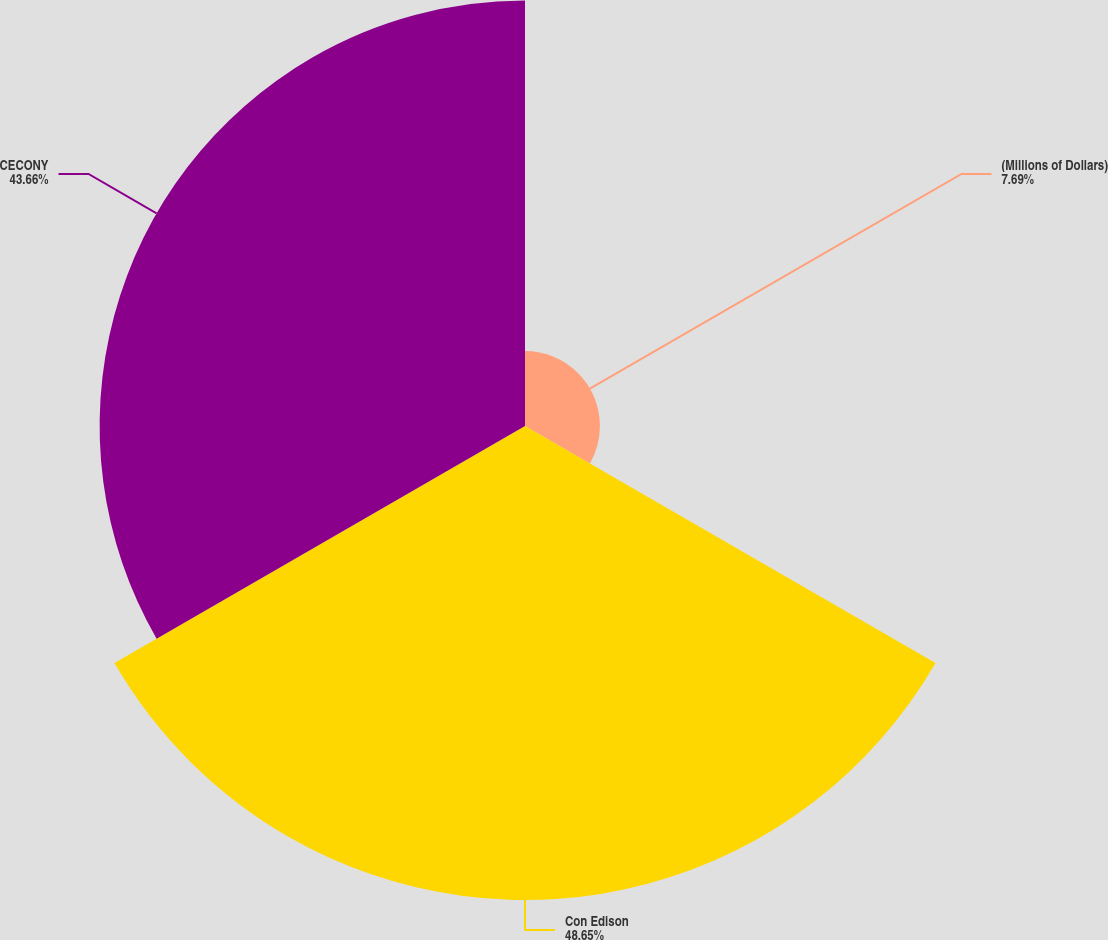Convert chart. <chart><loc_0><loc_0><loc_500><loc_500><pie_chart><fcel>(Millions of Dollars)<fcel>Con Edison<fcel>CECONY<nl><fcel>7.69%<fcel>48.65%<fcel>43.66%<nl></chart> 